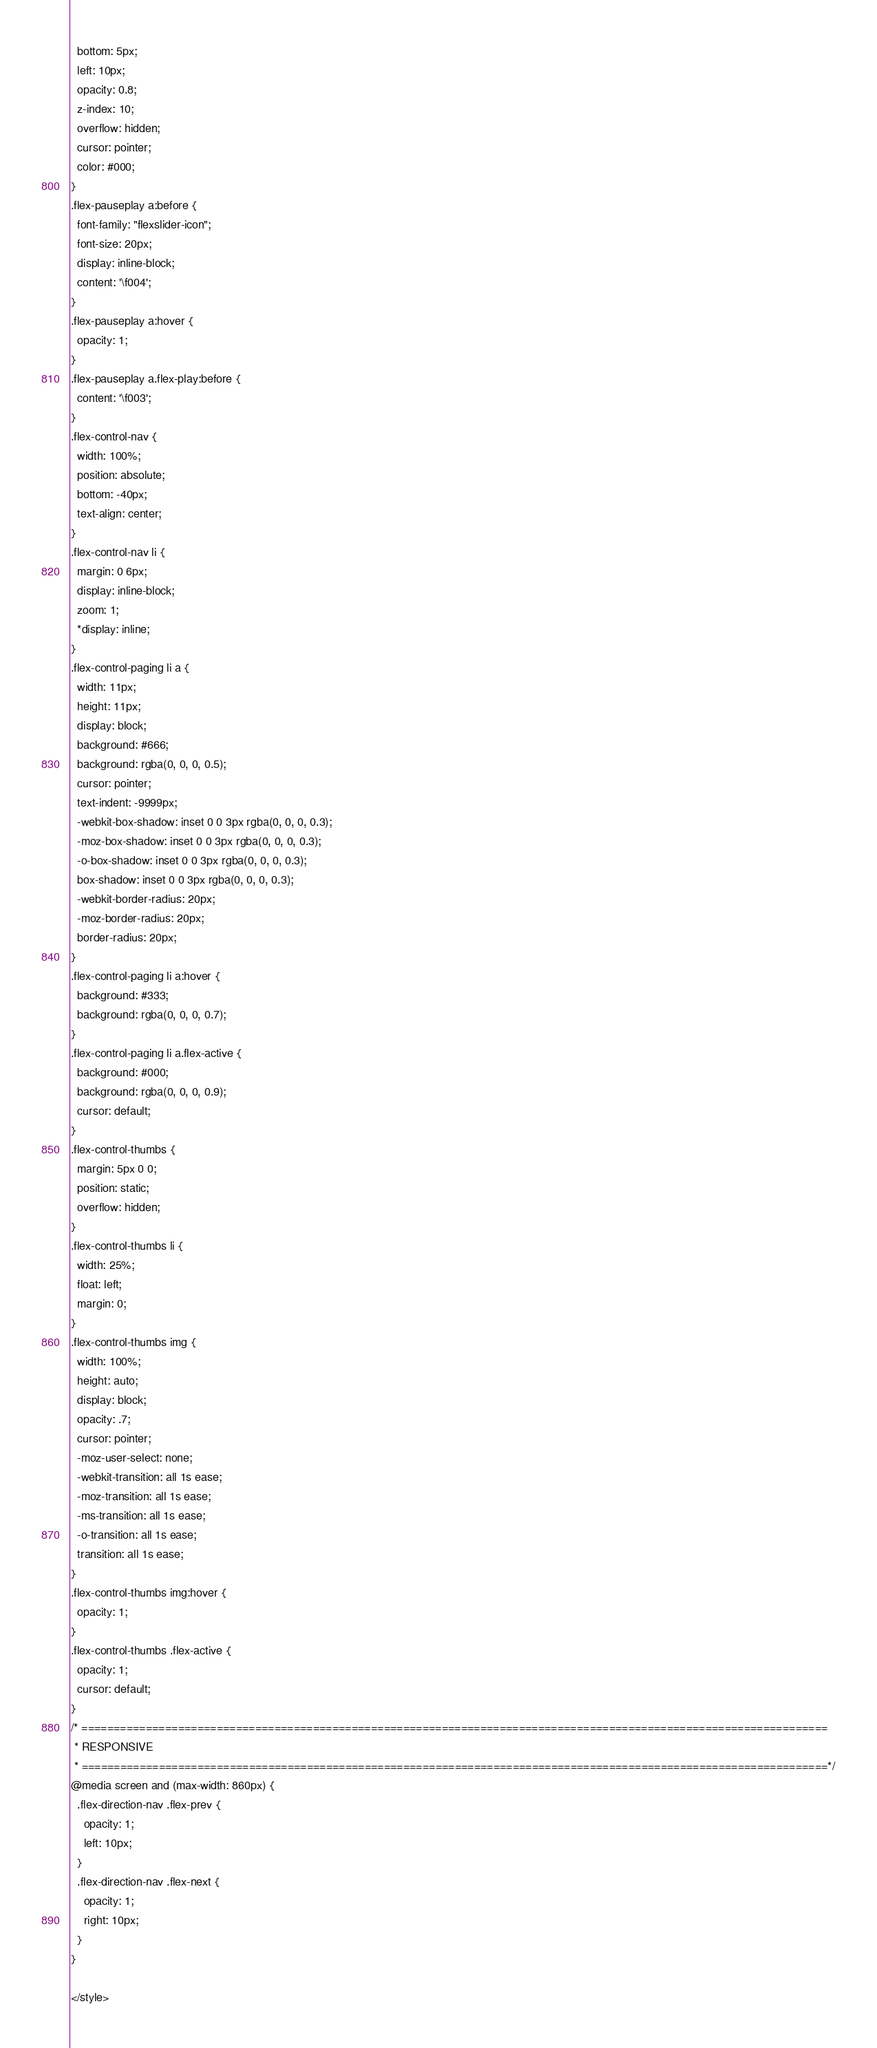<code> <loc_0><loc_0><loc_500><loc_500><_PHP_>  bottom: 5px;
  left: 10px;
  opacity: 0.8;
  z-index: 10;
  overflow: hidden;
  cursor: pointer;
  color: #000;
}
.flex-pauseplay a:before {
  font-family: "flexslider-icon";
  font-size: 20px;
  display: inline-block;
  content: '\f004';
}
.flex-pauseplay a:hover {
  opacity: 1;
}
.flex-pauseplay a.flex-play:before {
  content: '\f003';
}
.flex-control-nav {
  width: 100%;
  position: absolute;
  bottom: -40px;
  text-align: center;
}
.flex-control-nav li {
  margin: 0 6px;
  display: inline-block;
  zoom: 1;
  *display: inline;
}
.flex-control-paging li a {
  width: 11px;
  height: 11px;
  display: block;
  background: #666;
  background: rgba(0, 0, 0, 0.5);
  cursor: pointer;
  text-indent: -9999px;
  -webkit-box-shadow: inset 0 0 3px rgba(0, 0, 0, 0.3);
  -moz-box-shadow: inset 0 0 3px rgba(0, 0, 0, 0.3);
  -o-box-shadow: inset 0 0 3px rgba(0, 0, 0, 0.3);
  box-shadow: inset 0 0 3px rgba(0, 0, 0, 0.3);
  -webkit-border-radius: 20px;
  -moz-border-radius: 20px;
  border-radius: 20px;
}
.flex-control-paging li a:hover {
  background: #333;
  background: rgba(0, 0, 0, 0.7);
}
.flex-control-paging li a.flex-active {
  background: #000;
  background: rgba(0, 0, 0, 0.9);
  cursor: default;
}
.flex-control-thumbs {
  margin: 5px 0 0;
  position: static;
  overflow: hidden;
}
.flex-control-thumbs li {
  width: 25%;
  float: left;
  margin: 0;
}
.flex-control-thumbs img {
  width: 100%;
  height: auto;
  display: block;
  opacity: .7;
  cursor: pointer;
  -moz-user-select: none;
  -webkit-transition: all 1s ease;
  -moz-transition: all 1s ease;
  -ms-transition: all 1s ease;
  -o-transition: all 1s ease;
  transition: all 1s ease;
}
.flex-control-thumbs img:hover {
  opacity: 1;
}
.flex-control-thumbs .flex-active {
  opacity: 1;
  cursor: default;
}
/* ====================================================================================================================
 * RESPONSIVE
 * ====================================================================================================================*/
@media screen and (max-width: 860px) {
  .flex-direction-nav .flex-prev {
    opacity: 1;
    left: 10px;
  }
  .flex-direction-nav .flex-next {
    opacity: 1;
    right: 10px;
  }
}

</style></code> 